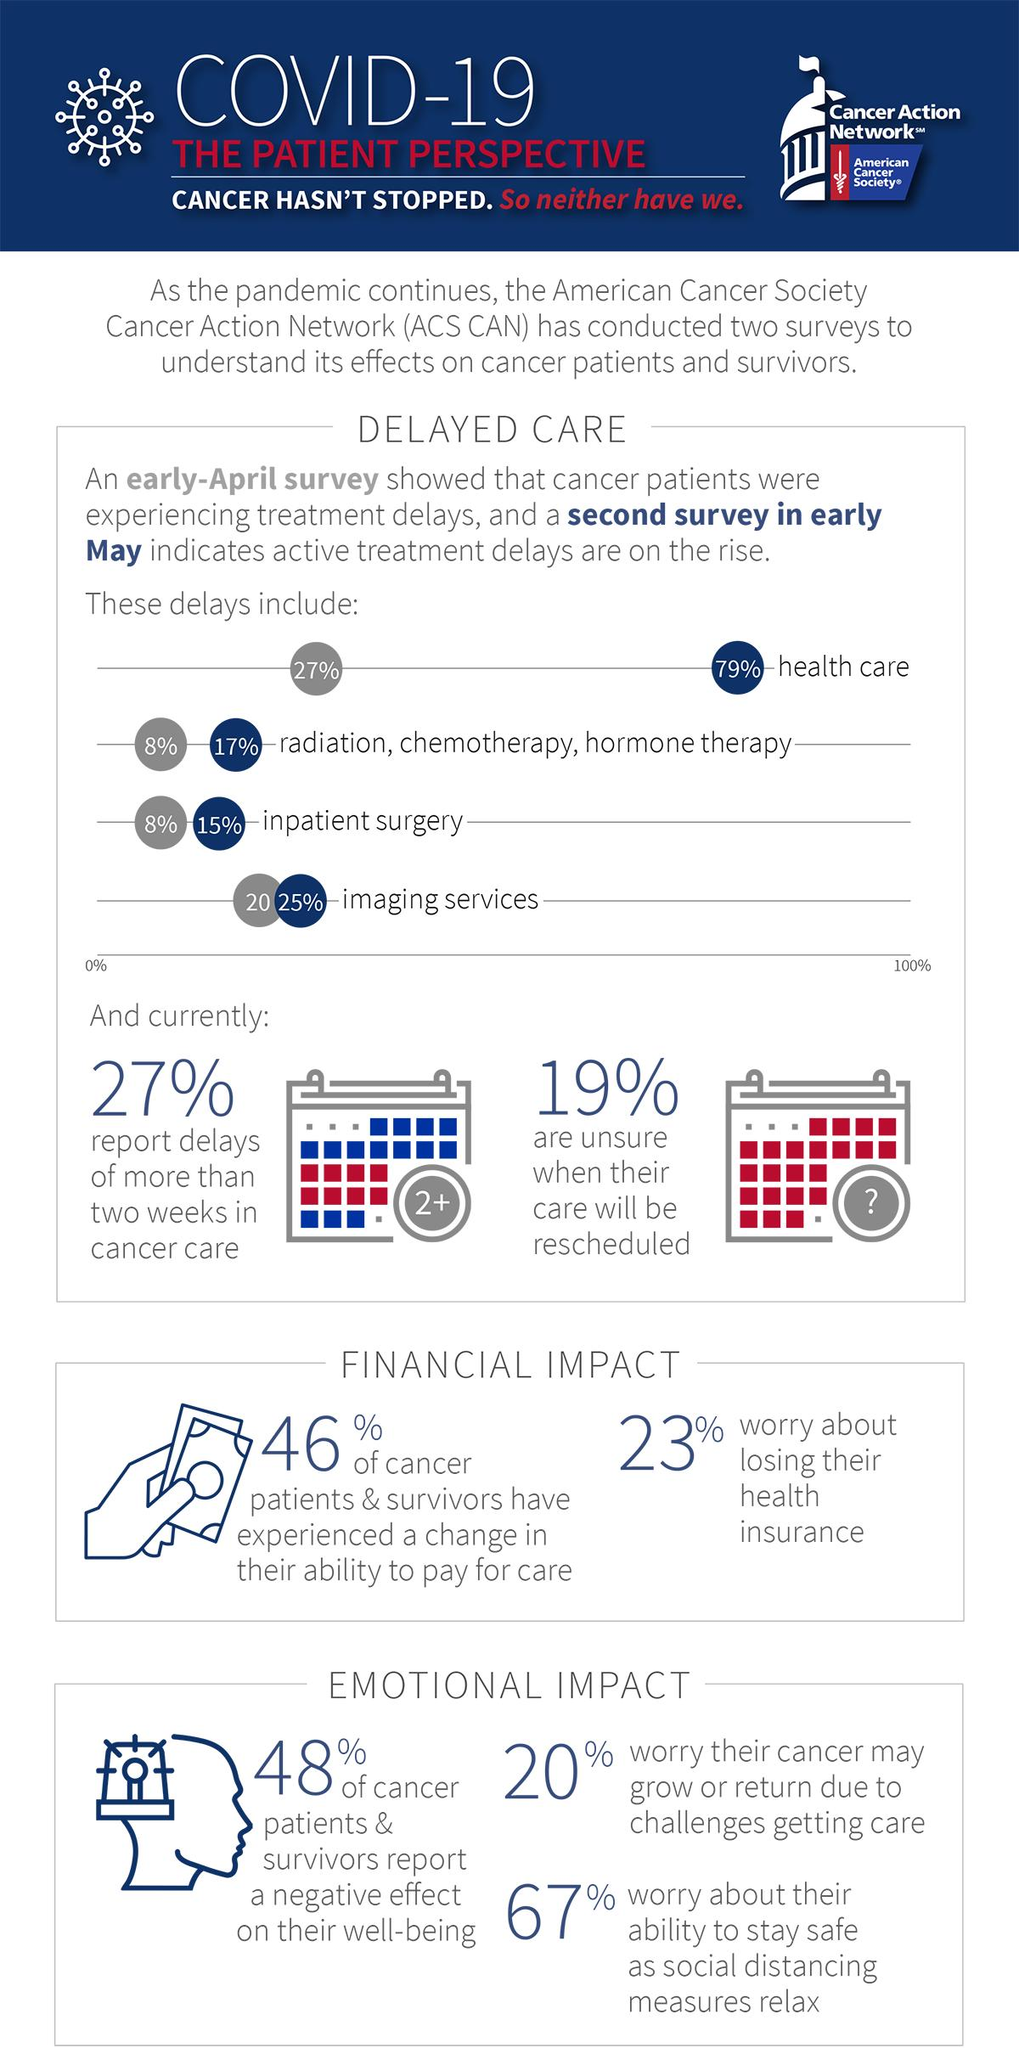Indicate a few pertinent items in this graphic. Approximately 27% of cancer patients reported having to wait more than two weeks for cancer care due to the impact of COVID-19, according to a recent survey. Eight percent of cancer patients surveyed in an early-April study conducted by ACS-CAN reported experiencing a delay in their inpatient surgery due to the COVID-19 pandemic. According to a survey conducted by ACS-CAN in early May, 25% of cancer patients reported experiencing a delay in imaging services due to the COVID-19 pandemic. A significant proportion of cancer patients, approximately 23%, worry about losing their health insurance due to the impact of COVID-19, highlighting the importance of addressing the needs of this vulnerable population during the pandemic. 